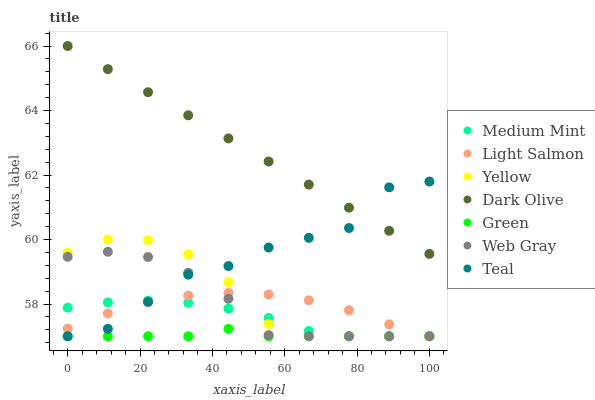Does Green have the minimum area under the curve?
Answer yes or no. Yes. Does Dark Olive have the maximum area under the curve?
Answer yes or no. Yes. Does Light Salmon have the minimum area under the curve?
Answer yes or no. No. Does Light Salmon have the maximum area under the curve?
Answer yes or no. No. Is Dark Olive the smoothest?
Answer yes or no. Yes. Is Teal the roughest?
Answer yes or no. Yes. Is Light Salmon the smoothest?
Answer yes or no. No. Is Light Salmon the roughest?
Answer yes or no. No. Does Medium Mint have the lowest value?
Answer yes or no. Yes. Does Dark Olive have the lowest value?
Answer yes or no. No. Does Dark Olive have the highest value?
Answer yes or no. Yes. Does Light Salmon have the highest value?
Answer yes or no. No. Is Medium Mint less than Dark Olive?
Answer yes or no. Yes. Is Dark Olive greater than Yellow?
Answer yes or no. Yes. Does Yellow intersect Medium Mint?
Answer yes or no. Yes. Is Yellow less than Medium Mint?
Answer yes or no. No. Is Yellow greater than Medium Mint?
Answer yes or no. No. Does Medium Mint intersect Dark Olive?
Answer yes or no. No. 